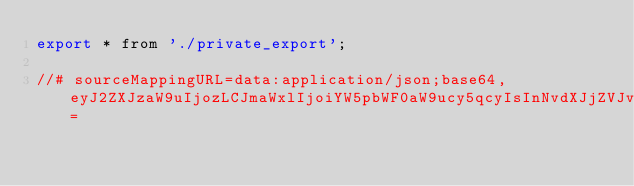Convert code to text. <code><loc_0><loc_0><loc_500><loc_500><_JavaScript_>export * from './private_export';

//# sourceMappingURL=data:application/json;base64,eyJ2ZXJzaW9uIjozLCJmaWxlIjoiYW5pbWF0aW9ucy5qcyIsInNvdXJjZVJvb3QiOiIiLCJzb3VyY2VzIjpbIi4uLy4uLy4uLy4uLy4uLy4uLy4uLy4uLy4uLy4uLy4uL3BhY2thZ2VzL3BsYXRmb3JtLWJyb3dzZXIvYW5pbWF0aW9ucy9zcmMvYW5pbWF0aW9ucy50cyJdLCJuYW1lcyI6W10sIm1hcHBpbmdzIjoiOzs7Ozs7O0FBYUEsT0FBTyxFQUFDLHVCQUF1QixFQUFFLG9CQUFvQixFQUFDLE1BQU0sVUFBVSxDQUFDO0FBRXZFLE9BQU8sRUFBQyxxQkFBcUIsRUFBQyxNQUFNLGFBQWEsQ0FBQztBQUVsRCxjQUFjLGtCQUFrQixDQUFDIiwic291cmNlc0NvbnRlbnQiOlsiLyoqXG4gKiBAbGljZW5zZVxuICogQ29weXJpZ2h0IEdvb2dsZSBJbmMuIEFsbCBSaWdodHMgUmVzZXJ2ZWQuXG4gKlxuICogVXNlIG9mIHRoaXMgc291cmNlIGNvZGUgaXMgZ292ZXJuZWQgYnkgYW4gTUlULXN0eWxlIGxpY2Vuc2UgdGhhdCBjYW4gYmVcbiAqIGZvdW5kIGluIHRoZSBMSUNFTlNFIGZpbGUgYXQgaHR0cHM6Ly9hbmd1bGFyLmlvL2xpY2Vuc2VcbiAqL1xuXG4vKipcbiAqIEBtb2R1bGVcbiAqIEBkZXNjcmlwdGlvblxuICogRW50cnkgcG9pbnQgZm9yIGFsbCBhbmltYXRpb24gQVBJcyBvZiB0aGUgYW5pbWF0aW9uIGJyb3dzZXIgcGFja2FnZS5cbiAqL1xuZXhwb3J0IHtCcm93c2VyQW5pbWF0aW9uc01vZHVsZSwgTm9vcEFuaW1hdGlvbnNNb2R1bGV9IGZyb20gJy4vbW9kdWxlJztcblxuZXhwb3J0IHtBTklNQVRJT05fTU9EVUxFX1RZUEV9IGZyb20gJy4vcHJvdmlkZXJzJztcblxuZXhwb3J0ICogZnJvbSAnLi9wcml2YXRlX2V4cG9ydCc7XG4iXX0=</code> 